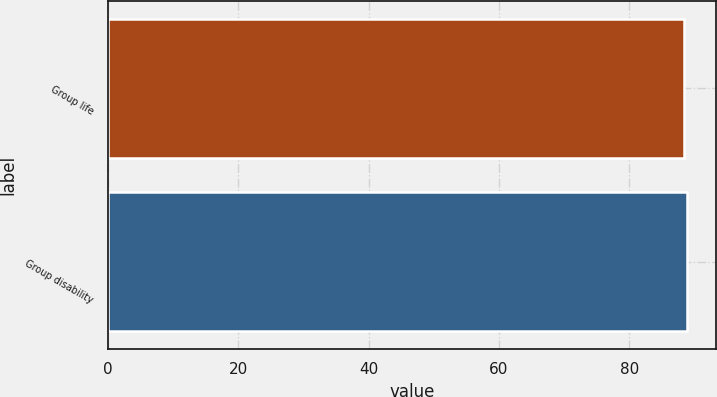Convert chart. <chart><loc_0><loc_0><loc_500><loc_500><bar_chart><fcel>Group life<fcel>Group disability<nl><fcel>88.4<fcel>88.9<nl></chart> 